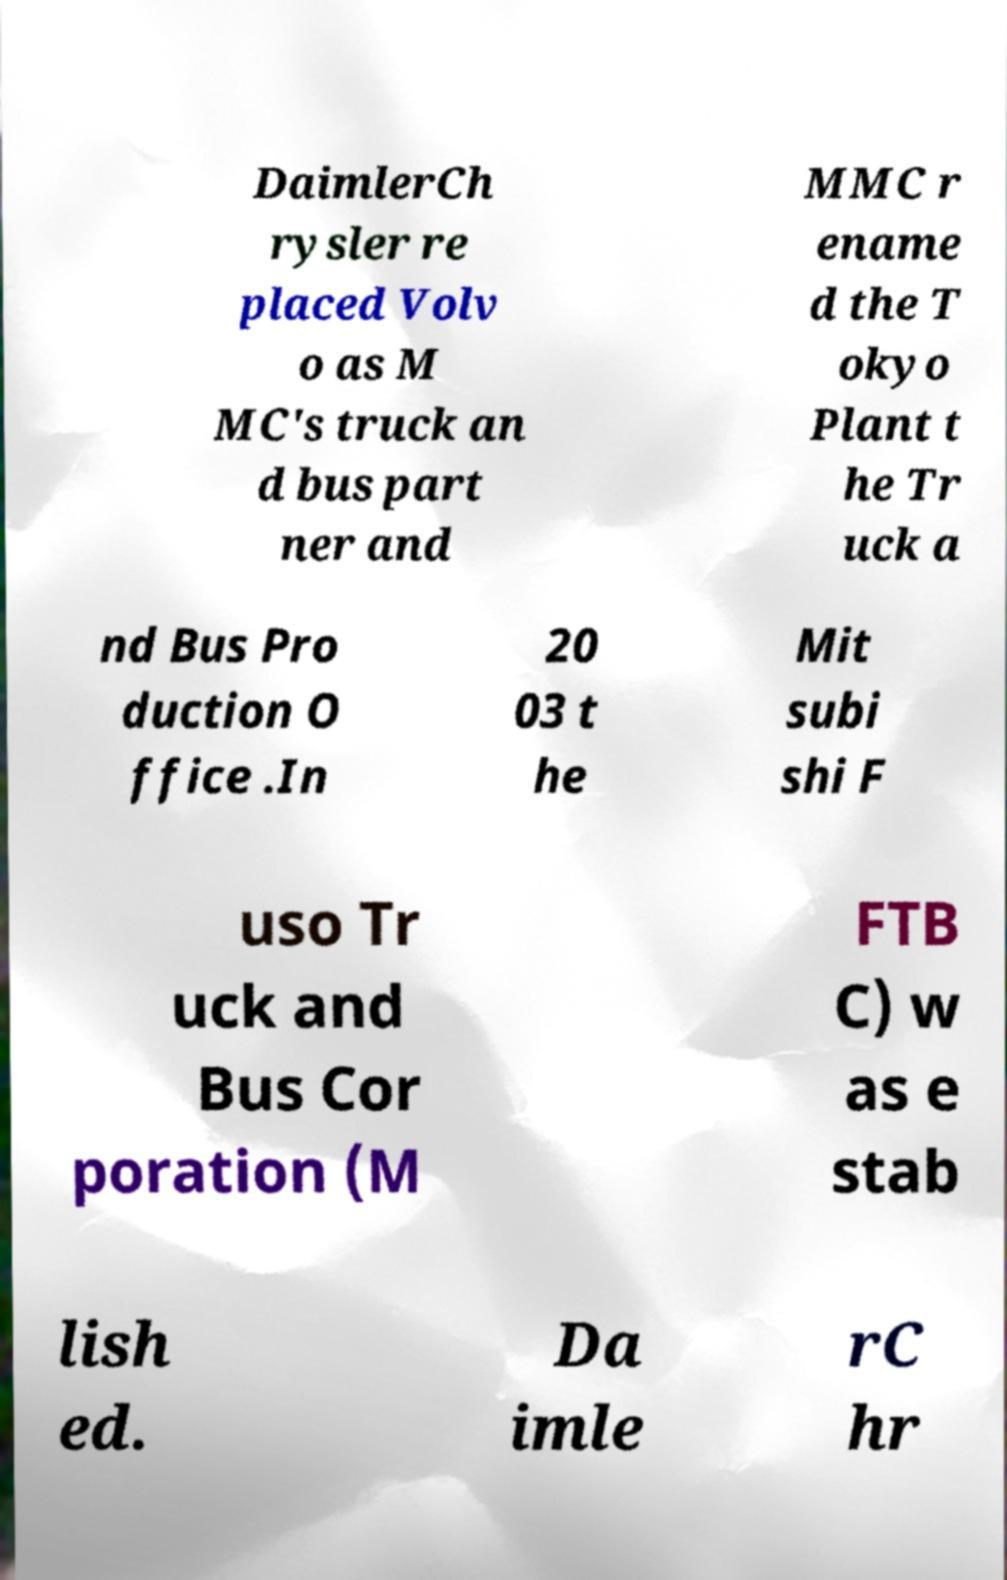Please identify and transcribe the text found in this image. DaimlerCh rysler re placed Volv o as M MC's truck an d bus part ner and MMC r ename d the T okyo Plant t he Tr uck a nd Bus Pro duction O ffice .In 20 03 t he Mit subi shi F uso Tr uck and Bus Cor poration (M FTB C) w as e stab lish ed. Da imle rC hr 